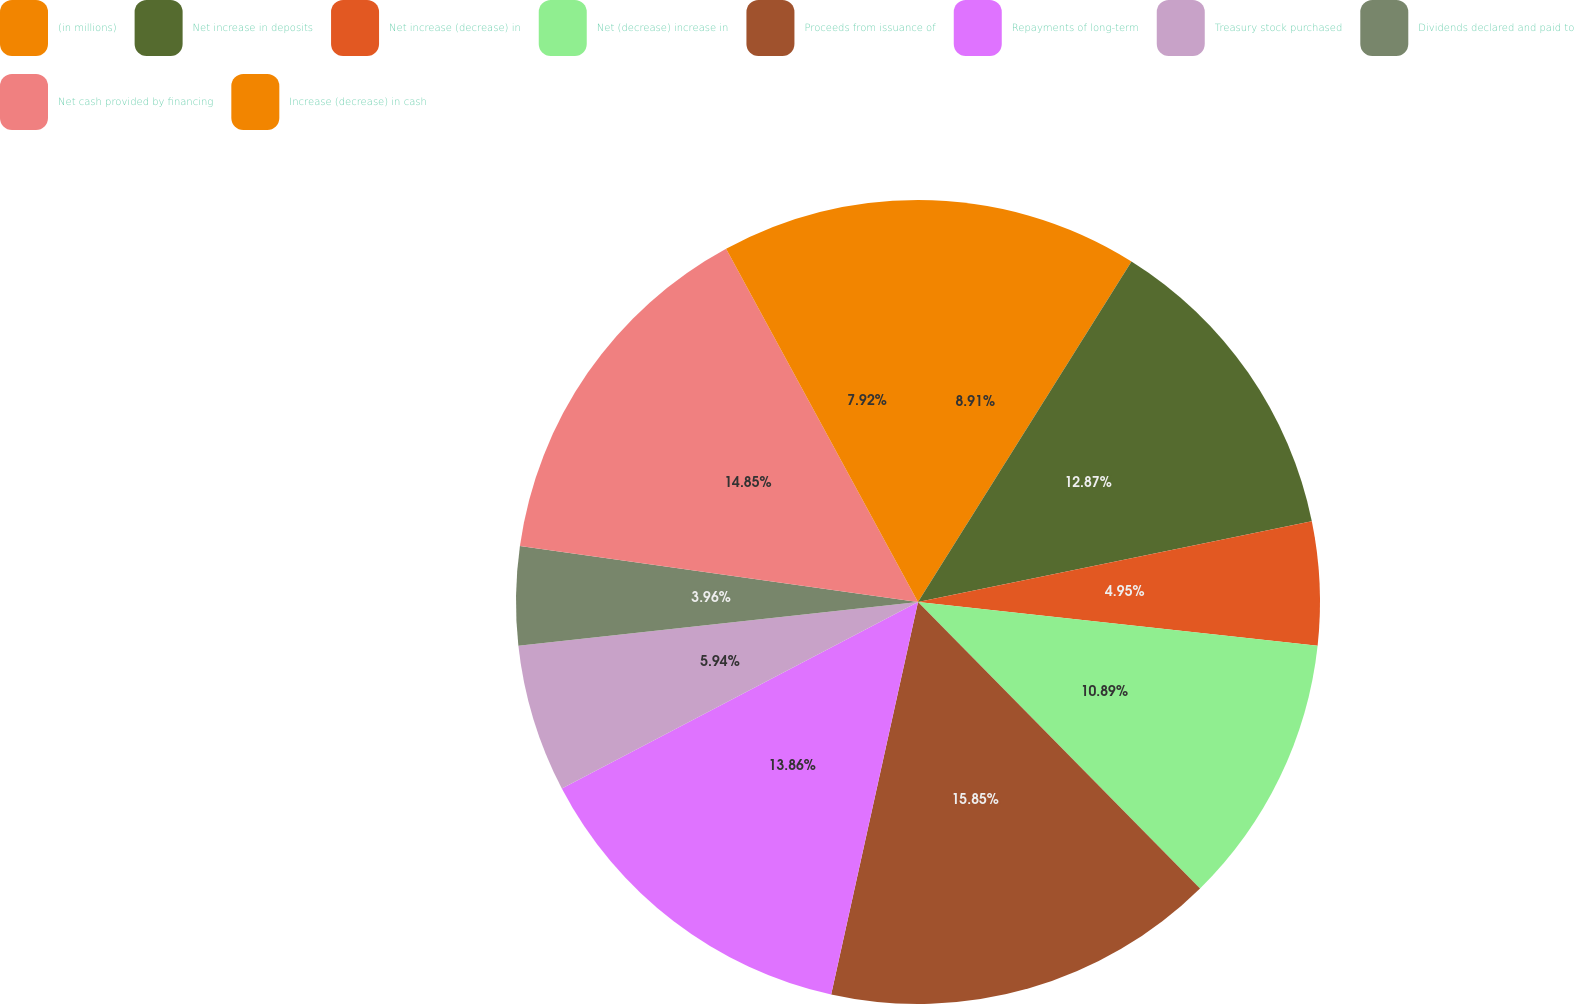<chart> <loc_0><loc_0><loc_500><loc_500><pie_chart><fcel>(in millions)<fcel>Net increase in deposits<fcel>Net increase (decrease) in<fcel>Net (decrease) increase in<fcel>Proceeds from issuance of<fcel>Repayments of long-term<fcel>Treasury stock purchased<fcel>Dividends declared and paid to<fcel>Net cash provided by financing<fcel>Increase (decrease) in cash<nl><fcel>8.91%<fcel>12.87%<fcel>4.95%<fcel>10.89%<fcel>15.84%<fcel>13.86%<fcel>5.94%<fcel>3.96%<fcel>14.85%<fcel>7.92%<nl></chart> 